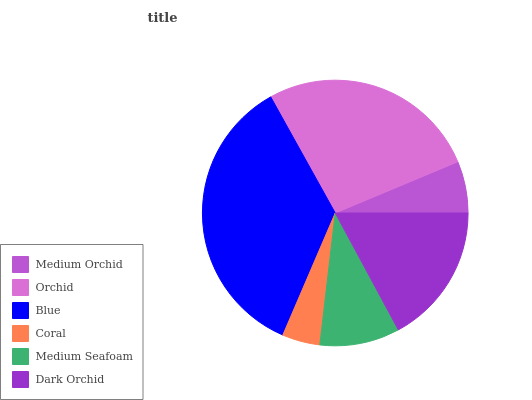Is Coral the minimum?
Answer yes or no. Yes. Is Blue the maximum?
Answer yes or no. Yes. Is Orchid the minimum?
Answer yes or no. No. Is Orchid the maximum?
Answer yes or no. No. Is Orchid greater than Medium Orchid?
Answer yes or no. Yes. Is Medium Orchid less than Orchid?
Answer yes or no. Yes. Is Medium Orchid greater than Orchid?
Answer yes or no. No. Is Orchid less than Medium Orchid?
Answer yes or no. No. Is Dark Orchid the high median?
Answer yes or no. Yes. Is Medium Seafoam the low median?
Answer yes or no. Yes. Is Coral the high median?
Answer yes or no. No. Is Orchid the low median?
Answer yes or no. No. 